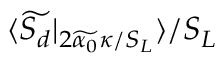Convert formula to latex. <formula><loc_0><loc_0><loc_500><loc_500>\langle \widetilde { S _ { d } } | _ { 2 \widetilde { \alpha _ { 0 } } \kappa / S _ { L } } \rangle / S _ { L }</formula> 